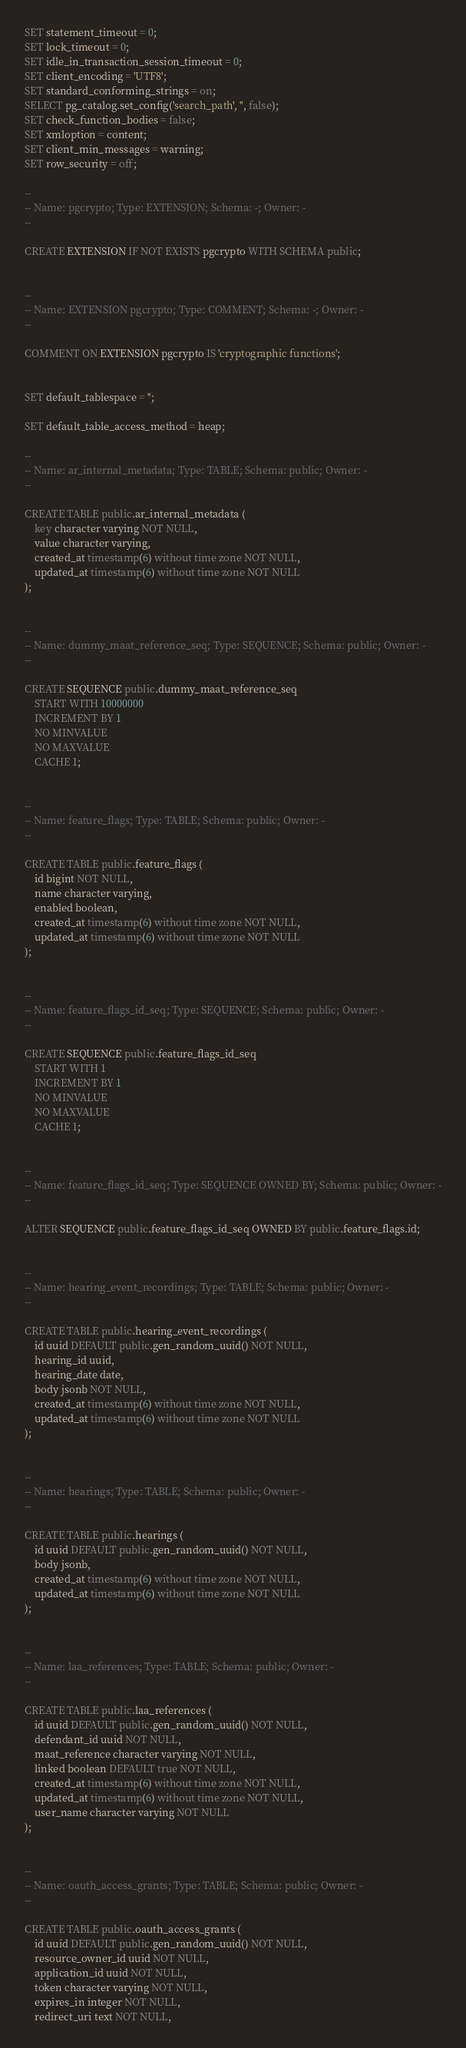<code> <loc_0><loc_0><loc_500><loc_500><_SQL_>SET statement_timeout = 0;
SET lock_timeout = 0;
SET idle_in_transaction_session_timeout = 0;
SET client_encoding = 'UTF8';
SET standard_conforming_strings = on;
SELECT pg_catalog.set_config('search_path', '', false);
SET check_function_bodies = false;
SET xmloption = content;
SET client_min_messages = warning;
SET row_security = off;

--
-- Name: pgcrypto; Type: EXTENSION; Schema: -; Owner: -
--

CREATE EXTENSION IF NOT EXISTS pgcrypto WITH SCHEMA public;


--
-- Name: EXTENSION pgcrypto; Type: COMMENT; Schema: -; Owner: -
--

COMMENT ON EXTENSION pgcrypto IS 'cryptographic functions';


SET default_tablespace = '';

SET default_table_access_method = heap;

--
-- Name: ar_internal_metadata; Type: TABLE; Schema: public; Owner: -
--

CREATE TABLE public.ar_internal_metadata (
    key character varying NOT NULL,
    value character varying,
    created_at timestamp(6) without time zone NOT NULL,
    updated_at timestamp(6) without time zone NOT NULL
);


--
-- Name: dummy_maat_reference_seq; Type: SEQUENCE; Schema: public; Owner: -
--

CREATE SEQUENCE public.dummy_maat_reference_seq
    START WITH 10000000
    INCREMENT BY 1
    NO MINVALUE
    NO MAXVALUE
    CACHE 1;


--
-- Name: feature_flags; Type: TABLE; Schema: public; Owner: -
--

CREATE TABLE public.feature_flags (
    id bigint NOT NULL,
    name character varying,
    enabled boolean,
    created_at timestamp(6) without time zone NOT NULL,
    updated_at timestamp(6) without time zone NOT NULL
);


--
-- Name: feature_flags_id_seq; Type: SEQUENCE; Schema: public; Owner: -
--

CREATE SEQUENCE public.feature_flags_id_seq
    START WITH 1
    INCREMENT BY 1
    NO MINVALUE
    NO MAXVALUE
    CACHE 1;


--
-- Name: feature_flags_id_seq; Type: SEQUENCE OWNED BY; Schema: public; Owner: -
--

ALTER SEQUENCE public.feature_flags_id_seq OWNED BY public.feature_flags.id;


--
-- Name: hearing_event_recordings; Type: TABLE; Schema: public; Owner: -
--

CREATE TABLE public.hearing_event_recordings (
    id uuid DEFAULT public.gen_random_uuid() NOT NULL,
    hearing_id uuid,
    hearing_date date,
    body jsonb NOT NULL,
    created_at timestamp(6) without time zone NOT NULL,
    updated_at timestamp(6) without time zone NOT NULL
);


--
-- Name: hearings; Type: TABLE; Schema: public; Owner: -
--

CREATE TABLE public.hearings (
    id uuid DEFAULT public.gen_random_uuid() NOT NULL,
    body jsonb,
    created_at timestamp(6) without time zone NOT NULL,
    updated_at timestamp(6) without time zone NOT NULL
);


--
-- Name: laa_references; Type: TABLE; Schema: public; Owner: -
--

CREATE TABLE public.laa_references (
    id uuid DEFAULT public.gen_random_uuid() NOT NULL,
    defendant_id uuid NOT NULL,
    maat_reference character varying NOT NULL,
    linked boolean DEFAULT true NOT NULL,
    created_at timestamp(6) without time zone NOT NULL,
    updated_at timestamp(6) without time zone NOT NULL,
    user_name character varying NOT NULL
);


--
-- Name: oauth_access_grants; Type: TABLE; Schema: public; Owner: -
--

CREATE TABLE public.oauth_access_grants (
    id uuid DEFAULT public.gen_random_uuid() NOT NULL,
    resource_owner_id uuid NOT NULL,
    application_id uuid NOT NULL,
    token character varying NOT NULL,
    expires_in integer NOT NULL,
    redirect_uri text NOT NULL,</code> 